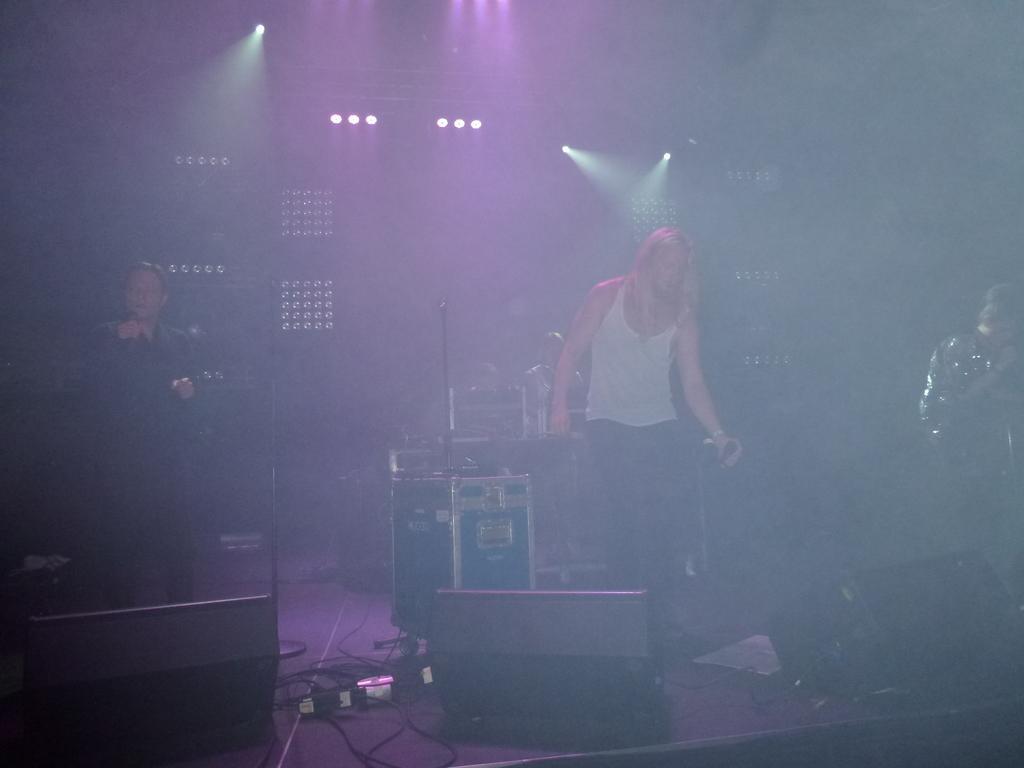Can you describe this image briefly? In this image we can see four persons, among them three persons are holding the mics, we can see some lights, cables, mics and some other objects on the stage, in the background we can see the wall with some focus lights. 